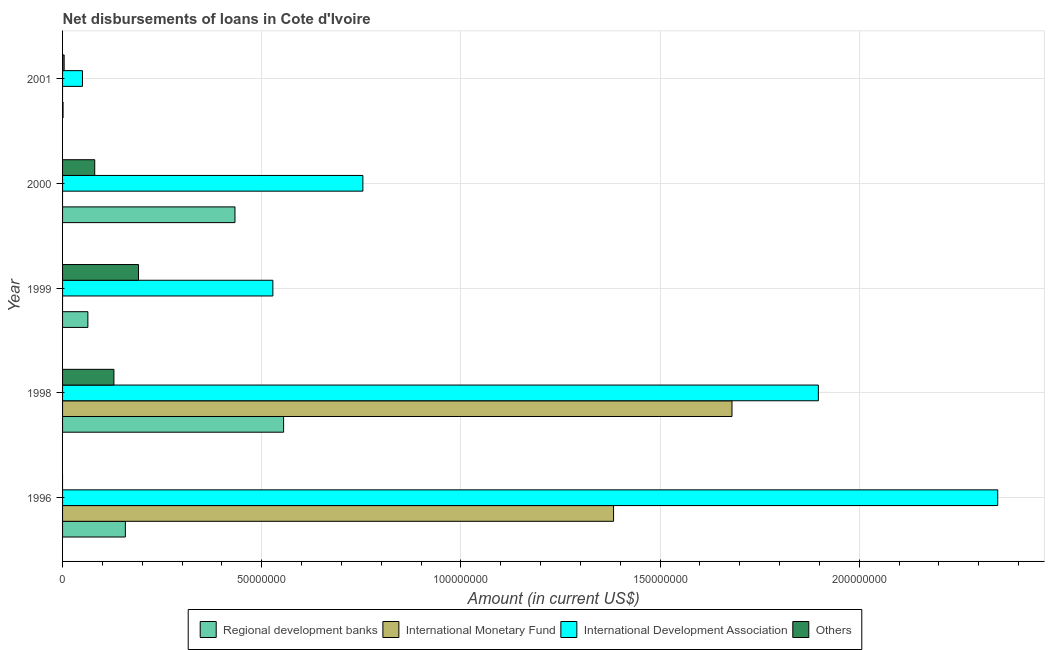How many different coloured bars are there?
Your response must be concise. 4. Are the number of bars on each tick of the Y-axis equal?
Provide a succinct answer. No. How many bars are there on the 2nd tick from the bottom?
Your answer should be compact. 4. What is the label of the 1st group of bars from the top?
Make the answer very short. 2001. What is the amount of loan disimbursed by international monetary fund in 1998?
Keep it short and to the point. 1.68e+08. Across all years, what is the maximum amount of loan disimbursed by international monetary fund?
Your answer should be very brief. 1.68e+08. Across all years, what is the minimum amount of loan disimbursed by other organisations?
Provide a succinct answer. 0. What is the total amount of loan disimbursed by other organisations in the graph?
Give a very brief answer. 4.04e+07. What is the difference between the amount of loan disimbursed by regional development banks in 1996 and that in 1998?
Ensure brevity in your answer.  -3.97e+07. What is the difference between the amount of loan disimbursed by international development association in 2000 and the amount of loan disimbursed by other organisations in 1998?
Offer a very short reply. 6.25e+07. What is the average amount of loan disimbursed by other organisations per year?
Your answer should be compact. 8.09e+06. In the year 1999, what is the difference between the amount of loan disimbursed by regional development banks and amount of loan disimbursed by international development association?
Keep it short and to the point. -4.64e+07. In how many years, is the amount of loan disimbursed by international monetary fund greater than 140000000 US$?
Your answer should be very brief. 1. What is the ratio of the amount of loan disimbursed by regional development banks in 1998 to that in 2000?
Offer a very short reply. 1.28. Is the amount of loan disimbursed by regional development banks in 1996 less than that in 1999?
Your answer should be very brief. No. What is the difference between the highest and the second highest amount of loan disimbursed by other organisations?
Provide a succinct answer. 6.18e+06. What is the difference between the highest and the lowest amount of loan disimbursed by international monetary fund?
Provide a short and direct response. 1.68e+08. Is it the case that in every year, the sum of the amount of loan disimbursed by regional development banks and amount of loan disimbursed by international monetary fund is greater than the amount of loan disimbursed by international development association?
Your answer should be compact. No. How many bars are there?
Your response must be concise. 16. What is the difference between two consecutive major ticks on the X-axis?
Your answer should be very brief. 5.00e+07. Does the graph contain any zero values?
Give a very brief answer. Yes. Does the graph contain grids?
Offer a terse response. Yes. What is the title of the graph?
Provide a short and direct response. Net disbursements of loans in Cote d'Ivoire. Does "HFC gas" appear as one of the legend labels in the graph?
Make the answer very short. No. What is the label or title of the X-axis?
Provide a short and direct response. Amount (in current US$). What is the label or title of the Y-axis?
Provide a succinct answer. Year. What is the Amount (in current US$) of Regional development banks in 1996?
Provide a succinct answer. 1.58e+07. What is the Amount (in current US$) in International Monetary Fund in 1996?
Your answer should be very brief. 1.38e+08. What is the Amount (in current US$) of International Development Association in 1996?
Your answer should be very brief. 2.35e+08. What is the Amount (in current US$) in Others in 1996?
Your answer should be very brief. 0. What is the Amount (in current US$) in Regional development banks in 1998?
Your response must be concise. 5.55e+07. What is the Amount (in current US$) of International Monetary Fund in 1998?
Your answer should be very brief. 1.68e+08. What is the Amount (in current US$) in International Development Association in 1998?
Keep it short and to the point. 1.90e+08. What is the Amount (in current US$) of Others in 1998?
Ensure brevity in your answer.  1.29e+07. What is the Amount (in current US$) of Regional development banks in 1999?
Provide a short and direct response. 6.36e+06. What is the Amount (in current US$) of International Monetary Fund in 1999?
Provide a succinct answer. 0. What is the Amount (in current US$) in International Development Association in 1999?
Make the answer very short. 5.28e+07. What is the Amount (in current US$) in Others in 1999?
Offer a very short reply. 1.91e+07. What is the Amount (in current US$) of Regional development banks in 2000?
Provide a succinct answer. 4.33e+07. What is the Amount (in current US$) in International Monetary Fund in 2000?
Make the answer very short. 0. What is the Amount (in current US$) in International Development Association in 2000?
Provide a succinct answer. 7.54e+07. What is the Amount (in current US$) in Others in 2000?
Provide a succinct answer. 8.08e+06. What is the Amount (in current US$) in Regional development banks in 2001?
Provide a succinct answer. 1.22e+05. What is the Amount (in current US$) of International Monetary Fund in 2001?
Your answer should be compact. 0. What is the Amount (in current US$) of International Development Association in 2001?
Your answer should be compact. 5.00e+06. What is the Amount (in current US$) in Others in 2001?
Your answer should be compact. 3.97e+05. Across all years, what is the maximum Amount (in current US$) in Regional development banks?
Offer a very short reply. 5.55e+07. Across all years, what is the maximum Amount (in current US$) in International Monetary Fund?
Offer a terse response. 1.68e+08. Across all years, what is the maximum Amount (in current US$) in International Development Association?
Keep it short and to the point. 2.35e+08. Across all years, what is the maximum Amount (in current US$) in Others?
Make the answer very short. 1.91e+07. Across all years, what is the minimum Amount (in current US$) of Regional development banks?
Make the answer very short. 1.22e+05. Across all years, what is the minimum Amount (in current US$) in International Monetary Fund?
Offer a very short reply. 0. Across all years, what is the minimum Amount (in current US$) in International Development Association?
Provide a short and direct response. 5.00e+06. What is the total Amount (in current US$) of Regional development banks in the graph?
Keep it short and to the point. 1.21e+08. What is the total Amount (in current US$) of International Monetary Fund in the graph?
Give a very brief answer. 3.06e+08. What is the total Amount (in current US$) in International Development Association in the graph?
Make the answer very short. 5.58e+08. What is the total Amount (in current US$) in Others in the graph?
Offer a terse response. 4.04e+07. What is the difference between the Amount (in current US$) in Regional development banks in 1996 and that in 1998?
Provide a succinct answer. -3.97e+07. What is the difference between the Amount (in current US$) of International Monetary Fund in 1996 and that in 1998?
Your answer should be compact. -2.97e+07. What is the difference between the Amount (in current US$) in International Development Association in 1996 and that in 1998?
Offer a terse response. 4.50e+07. What is the difference between the Amount (in current US$) of Regional development banks in 1996 and that in 1999?
Provide a succinct answer. 9.41e+06. What is the difference between the Amount (in current US$) of International Development Association in 1996 and that in 1999?
Offer a very short reply. 1.82e+08. What is the difference between the Amount (in current US$) in Regional development banks in 1996 and that in 2000?
Give a very brief answer. -2.75e+07. What is the difference between the Amount (in current US$) of International Development Association in 1996 and that in 2000?
Your answer should be very brief. 1.59e+08. What is the difference between the Amount (in current US$) of Regional development banks in 1996 and that in 2001?
Provide a short and direct response. 1.56e+07. What is the difference between the Amount (in current US$) of International Development Association in 1996 and that in 2001?
Offer a terse response. 2.30e+08. What is the difference between the Amount (in current US$) of Regional development banks in 1998 and that in 1999?
Offer a terse response. 4.91e+07. What is the difference between the Amount (in current US$) in International Development Association in 1998 and that in 1999?
Offer a very short reply. 1.37e+08. What is the difference between the Amount (in current US$) of Others in 1998 and that in 1999?
Make the answer very short. -6.18e+06. What is the difference between the Amount (in current US$) of Regional development banks in 1998 and that in 2000?
Your answer should be compact. 1.22e+07. What is the difference between the Amount (in current US$) of International Development Association in 1998 and that in 2000?
Your answer should be compact. 1.14e+08. What is the difference between the Amount (in current US$) in Others in 1998 and that in 2000?
Offer a very short reply. 4.82e+06. What is the difference between the Amount (in current US$) of Regional development banks in 1998 and that in 2001?
Your answer should be very brief. 5.54e+07. What is the difference between the Amount (in current US$) in International Development Association in 1998 and that in 2001?
Your answer should be compact. 1.85e+08. What is the difference between the Amount (in current US$) in Others in 1998 and that in 2001?
Offer a very short reply. 1.25e+07. What is the difference between the Amount (in current US$) of Regional development banks in 1999 and that in 2000?
Your answer should be very brief. -3.69e+07. What is the difference between the Amount (in current US$) of International Development Association in 1999 and that in 2000?
Your answer should be compact. -2.26e+07. What is the difference between the Amount (in current US$) of Others in 1999 and that in 2000?
Your answer should be compact. 1.10e+07. What is the difference between the Amount (in current US$) in Regional development banks in 1999 and that in 2001?
Give a very brief answer. 6.23e+06. What is the difference between the Amount (in current US$) in International Development Association in 1999 and that in 2001?
Give a very brief answer. 4.78e+07. What is the difference between the Amount (in current US$) in Others in 1999 and that in 2001?
Keep it short and to the point. 1.87e+07. What is the difference between the Amount (in current US$) of Regional development banks in 2000 and that in 2001?
Make the answer very short. 4.32e+07. What is the difference between the Amount (in current US$) in International Development Association in 2000 and that in 2001?
Provide a succinct answer. 7.04e+07. What is the difference between the Amount (in current US$) in Others in 2000 and that in 2001?
Offer a very short reply. 7.68e+06. What is the difference between the Amount (in current US$) of Regional development banks in 1996 and the Amount (in current US$) of International Monetary Fund in 1998?
Keep it short and to the point. -1.52e+08. What is the difference between the Amount (in current US$) of Regional development banks in 1996 and the Amount (in current US$) of International Development Association in 1998?
Keep it short and to the point. -1.74e+08. What is the difference between the Amount (in current US$) in Regional development banks in 1996 and the Amount (in current US$) in Others in 1998?
Keep it short and to the point. 2.87e+06. What is the difference between the Amount (in current US$) of International Monetary Fund in 1996 and the Amount (in current US$) of International Development Association in 1998?
Provide a short and direct response. -5.14e+07. What is the difference between the Amount (in current US$) of International Monetary Fund in 1996 and the Amount (in current US$) of Others in 1998?
Give a very brief answer. 1.25e+08. What is the difference between the Amount (in current US$) in International Development Association in 1996 and the Amount (in current US$) in Others in 1998?
Offer a very short reply. 2.22e+08. What is the difference between the Amount (in current US$) in Regional development banks in 1996 and the Amount (in current US$) in International Development Association in 1999?
Offer a very short reply. -3.70e+07. What is the difference between the Amount (in current US$) of Regional development banks in 1996 and the Amount (in current US$) of Others in 1999?
Your answer should be very brief. -3.30e+06. What is the difference between the Amount (in current US$) of International Monetary Fund in 1996 and the Amount (in current US$) of International Development Association in 1999?
Offer a very short reply. 8.55e+07. What is the difference between the Amount (in current US$) in International Monetary Fund in 1996 and the Amount (in current US$) in Others in 1999?
Your answer should be very brief. 1.19e+08. What is the difference between the Amount (in current US$) of International Development Association in 1996 and the Amount (in current US$) of Others in 1999?
Your answer should be compact. 2.16e+08. What is the difference between the Amount (in current US$) of Regional development banks in 1996 and the Amount (in current US$) of International Development Association in 2000?
Make the answer very short. -5.96e+07. What is the difference between the Amount (in current US$) in Regional development banks in 1996 and the Amount (in current US$) in Others in 2000?
Give a very brief answer. 7.69e+06. What is the difference between the Amount (in current US$) of International Monetary Fund in 1996 and the Amount (in current US$) of International Development Association in 2000?
Offer a terse response. 6.29e+07. What is the difference between the Amount (in current US$) in International Monetary Fund in 1996 and the Amount (in current US$) in Others in 2000?
Offer a very short reply. 1.30e+08. What is the difference between the Amount (in current US$) in International Development Association in 1996 and the Amount (in current US$) in Others in 2000?
Give a very brief answer. 2.27e+08. What is the difference between the Amount (in current US$) of Regional development banks in 1996 and the Amount (in current US$) of International Development Association in 2001?
Offer a terse response. 1.08e+07. What is the difference between the Amount (in current US$) of Regional development banks in 1996 and the Amount (in current US$) of Others in 2001?
Offer a terse response. 1.54e+07. What is the difference between the Amount (in current US$) in International Monetary Fund in 1996 and the Amount (in current US$) in International Development Association in 2001?
Provide a succinct answer. 1.33e+08. What is the difference between the Amount (in current US$) of International Monetary Fund in 1996 and the Amount (in current US$) of Others in 2001?
Keep it short and to the point. 1.38e+08. What is the difference between the Amount (in current US$) in International Development Association in 1996 and the Amount (in current US$) in Others in 2001?
Offer a very short reply. 2.34e+08. What is the difference between the Amount (in current US$) in Regional development banks in 1998 and the Amount (in current US$) in International Development Association in 1999?
Provide a succinct answer. 2.70e+06. What is the difference between the Amount (in current US$) in Regional development banks in 1998 and the Amount (in current US$) in Others in 1999?
Ensure brevity in your answer.  3.64e+07. What is the difference between the Amount (in current US$) in International Monetary Fund in 1998 and the Amount (in current US$) in International Development Association in 1999?
Provide a succinct answer. 1.15e+08. What is the difference between the Amount (in current US$) in International Monetary Fund in 1998 and the Amount (in current US$) in Others in 1999?
Offer a very short reply. 1.49e+08. What is the difference between the Amount (in current US$) of International Development Association in 1998 and the Amount (in current US$) of Others in 1999?
Keep it short and to the point. 1.71e+08. What is the difference between the Amount (in current US$) in Regional development banks in 1998 and the Amount (in current US$) in International Development Association in 2000?
Ensure brevity in your answer.  -1.99e+07. What is the difference between the Amount (in current US$) of Regional development banks in 1998 and the Amount (in current US$) of Others in 2000?
Your response must be concise. 4.74e+07. What is the difference between the Amount (in current US$) in International Monetary Fund in 1998 and the Amount (in current US$) in International Development Association in 2000?
Provide a short and direct response. 9.27e+07. What is the difference between the Amount (in current US$) of International Monetary Fund in 1998 and the Amount (in current US$) of Others in 2000?
Your answer should be very brief. 1.60e+08. What is the difference between the Amount (in current US$) in International Development Association in 1998 and the Amount (in current US$) in Others in 2000?
Give a very brief answer. 1.82e+08. What is the difference between the Amount (in current US$) in Regional development banks in 1998 and the Amount (in current US$) in International Development Association in 2001?
Your answer should be very brief. 5.05e+07. What is the difference between the Amount (in current US$) of Regional development banks in 1998 and the Amount (in current US$) of Others in 2001?
Offer a terse response. 5.51e+07. What is the difference between the Amount (in current US$) of International Monetary Fund in 1998 and the Amount (in current US$) of International Development Association in 2001?
Offer a terse response. 1.63e+08. What is the difference between the Amount (in current US$) in International Monetary Fund in 1998 and the Amount (in current US$) in Others in 2001?
Give a very brief answer. 1.68e+08. What is the difference between the Amount (in current US$) of International Development Association in 1998 and the Amount (in current US$) of Others in 2001?
Provide a short and direct response. 1.89e+08. What is the difference between the Amount (in current US$) in Regional development banks in 1999 and the Amount (in current US$) in International Development Association in 2000?
Offer a very short reply. -6.90e+07. What is the difference between the Amount (in current US$) in Regional development banks in 1999 and the Amount (in current US$) in Others in 2000?
Your answer should be very brief. -1.72e+06. What is the difference between the Amount (in current US$) in International Development Association in 1999 and the Amount (in current US$) in Others in 2000?
Your answer should be very brief. 4.47e+07. What is the difference between the Amount (in current US$) of Regional development banks in 1999 and the Amount (in current US$) of International Development Association in 2001?
Your answer should be compact. 1.36e+06. What is the difference between the Amount (in current US$) of Regional development banks in 1999 and the Amount (in current US$) of Others in 2001?
Provide a succinct answer. 5.96e+06. What is the difference between the Amount (in current US$) in International Development Association in 1999 and the Amount (in current US$) in Others in 2001?
Keep it short and to the point. 5.24e+07. What is the difference between the Amount (in current US$) of Regional development banks in 2000 and the Amount (in current US$) of International Development Association in 2001?
Provide a short and direct response. 3.83e+07. What is the difference between the Amount (in current US$) in Regional development banks in 2000 and the Amount (in current US$) in Others in 2001?
Give a very brief answer. 4.29e+07. What is the difference between the Amount (in current US$) in International Development Association in 2000 and the Amount (in current US$) in Others in 2001?
Provide a short and direct response. 7.50e+07. What is the average Amount (in current US$) in Regional development banks per year?
Your answer should be very brief. 2.42e+07. What is the average Amount (in current US$) in International Monetary Fund per year?
Your answer should be very brief. 6.13e+07. What is the average Amount (in current US$) of International Development Association per year?
Keep it short and to the point. 1.12e+08. What is the average Amount (in current US$) of Others per year?
Offer a very short reply. 8.09e+06. In the year 1996, what is the difference between the Amount (in current US$) of Regional development banks and Amount (in current US$) of International Monetary Fund?
Make the answer very short. -1.23e+08. In the year 1996, what is the difference between the Amount (in current US$) of Regional development banks and Amount (in current US$) of International Development Association?
Give a very brief answer. -2.19e+08. In the year 1996, what is the difference between the Amount (in current US$) of International Monetary Fund and Amount (in current US$) of International Development Association?
Your answer should be very brief. -9.64e+07. In the year 1998, what is the difference between the Amount (in current US$) in Regional development banks and Amount (in current US$) in International Monetary Fund?
Keep it short and to the point. -1.13e+08. In the year 1998, what is the difference between the Amount (in current US$) in Regional development banks and Amount (in current US$) in International Development Association?
Your answer should be compact. -1.34e+08. In the year 1998, what is the difference between the Amount (in current US$) of Regional development banks and Amount (in current US$) of Others?
Your response must be concise. 4.26e+07. In the year 1998, what is the difference between the Amount (in current US$) in International Monetary Fund and Amount (in current US$) in International Development Association?
Your answer should be compact. -2.17e+07. In the year 1998, what is the difference between the Amount (in current US$) in International Monetary Fund and Amount (in current US$) in Others?
Keep it short and to the point. 1.55e+08. In the year 1998, what is the difference between the Amount (in current US$) of International Development Association and Amount (in current US$) of Others?
Your answer should be very brief. 1.77e+08. In the year 1999, what is the difference between the Amount (in current US$) in Regional development banks and Amount (in current US$) in International Development Association?
Your response must be concise. -4.64e+07. In the year 1999, what is the difference between the Amount (in current US$) in Regional development banks and Amount (in current US$) in Others?
Keep it short and to the point. -1.27e+07. In the year 1999, what is the difference between the Amount (in current US$) of International Development Association and Amount (in current US$) of Others?
Give a very brief answer. 3.37e+07. In the year 2000, what is the difference between the Amount (in current US$) of Regional development banks and Amount (in current US$) of International Development Association?
Offer a terse response. -3.21e+07. In the year 2000, what is the difference between the Amount (in current US$) in Regional development banks and Amount (in current US$) in Others?
Provide a short and direct response. 3.52e+07. In the year 2000, what is the difference between the Amount (in current US$) in International Development Association and Amount (in current US$) in Others?
Ensure brevity in your answer.  6.73e+07. In the year 2001, what is the difference between the Amount (in current US$) in Regional development banks and Amount (in current US$) in International Development Association?
Ensure brevity in your answer.  -4.87e+06. In the year 2001, what is the difference between the Amount (in current US$) of Regional development banks and Amount (in current US$) of Others?
Ensure brevity in your answer.  -2.75e+05. In the year 2001, what is the difference between the Amount (in current US$) in International Development Association and Amount (in current US$) in Others?
Your answer should be very brief. 4.60e+06. What is the ratio of the Amount (in current US$) of Regional development banks in 1996 to that in 1998?
Provide a succinct answer. 0.28. What is the ratio of the Amount (in current US$) in International Monetary Fund in 1996 to that in 1998?
Your answer should be compact. 0.82. What is the ratio of the Amount (in current US$) in International Development Association in 1996 to that in 1998?
Ensure brevity in your answer.  1.24. What is the ratio of the Amount (in current US$) of Regional development banks in 1996 to that in 1999?
Offer a very short reply. 2.48. What is the ratio of the Amount (in current US$) in International Development Association in 1996 to that in 1999?
Your response must be concise. 4.45. What is the ratio of the Amount (in current US$) of Regional development banks in 1996 to that in 2000?
Keep it short and to the point. 0.36. What is the ratio of the Amount (in current US$) of International Development Association in 1996 to that in 2000?
Your answer should be very brief. 3.11. What is the ratio of the Amount (in current US$) in Regional development banks in 1996 to that in 2001?
Ensure brevity in your answer.  129.23. What is the ratio of the Amount (in current US$) of International Development Association in 1996 to that in 2001?
Your response must be concise. 46.99. What is the ratio of the Amount (in current US$) of Regional development banks in 1998 to that in 1999?
Provide a succinct answer. 8.73. What is the ratio of the Amount (in current US$) of International Development Association in 1998 to that in 1999?
Give a very brief answer. 3.59. What is the ratio of the Amount (in current US$) of Others in 1998 to that in 1999?
Provide a succinct answer. 0.68. What is the ratio of the Amount (in current US$) of Regional development banks in 1998 to that in 2000?
Offer a very short reply. 1.28. What is the ratio of the Amount (in current US$) in International Development Association in 1998 to that in 2000?
Provide a succinct answer. 2.52. What is the ratio of the Amount (in current US$) in Others in 1998 to that in 2000?
Offer a terse response. 1.6. What is the ratio of the Amount (in current US$) of Regional development banks in 1998 to that in 2001?
Your answer should be compact. 454.87. What is the ratio of the Amount (in current US$) of International Development Association in 1998 to that in 2001?
Provide a short and direct response. 37.98. What is the ratio of the Amount (in current US$) of Others in 1998 to that in 2001?
Ensure brevity in your answer.  32.47. What is the ratio of the Amount (in current US$) in Regional development banks in 1999 to that in 2000?
Give a very brief answer. 0.15. What is the ratio of the Amount (in current US$) of International Development Association in 1999 to that in 2000?
Provide a short and direct response. 0.7. What is the ratio of the Amount (in current US$) in Others in 1999 to that in 2000?
Give a very brief answer. 2.36. What is the ratio of the Amount (in current US$) of Regional development banks in 1999 to that in 2001?
Provide a succinct answer. 52.09. What is the ratio of the Amount (in current US$) of International Development Association in 1999 to that in 2001?
Keep it short and to the point. 10.57. What is the ratio of the Amount (in current US$) in Others in 1999 to that in 2001?
Offer a very short reply. 48.03. What is the ratio of the Amount (in current US$) in Regional development banks in 2000 to that in 2001?
Your answer should be compact. 354.77. What is the ratio of the Amount (in current US$) of International Development Association in 2000 to that in 2001?
Offer a very short reply. 15.09. What is the ratio of the Amount (in current US$) in Others in 2000 to that in 2001?
Provide a short and direct response. 20.34. What is the difference between the highest and the second highest Amount (in current US$) in Regional development banks?
Provide a short and direct response. 1.22e+07. What is the difference between the highest and the second highest Amount (in current US$) of International Development Association?
Your answer should be compact. 4.50e+07. What is the difference between the highest and the second highest Amount (in current US$) in Others?
Your answer should be very brief. 6.18e+06. What is the difference between the highest and the lowest Amount (in current US$) of Regional development banks?
Offer a terse response. 5.54e+07. What is the difference between the highest and the lowest Amount (in current US$) in International Monetary Fund?
Provide a succinct answer. 1.68e+08. What is the difference between the highest and the lowest Amount (in current US$) of International Development Association?
Make the answer very short. 2.30e+08. What is the difference between the highest and the lowest Amount (in current US$) of Others?
Provide a succinct answer. 1.91e+07. 